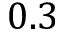<formula> <loc_0><loc_0><loc_500><loc_500>0 . 3</formula> 